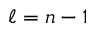<formula> <loc_0><loc_0><loc_500><loc_500>\ell = n - 1</formula> 